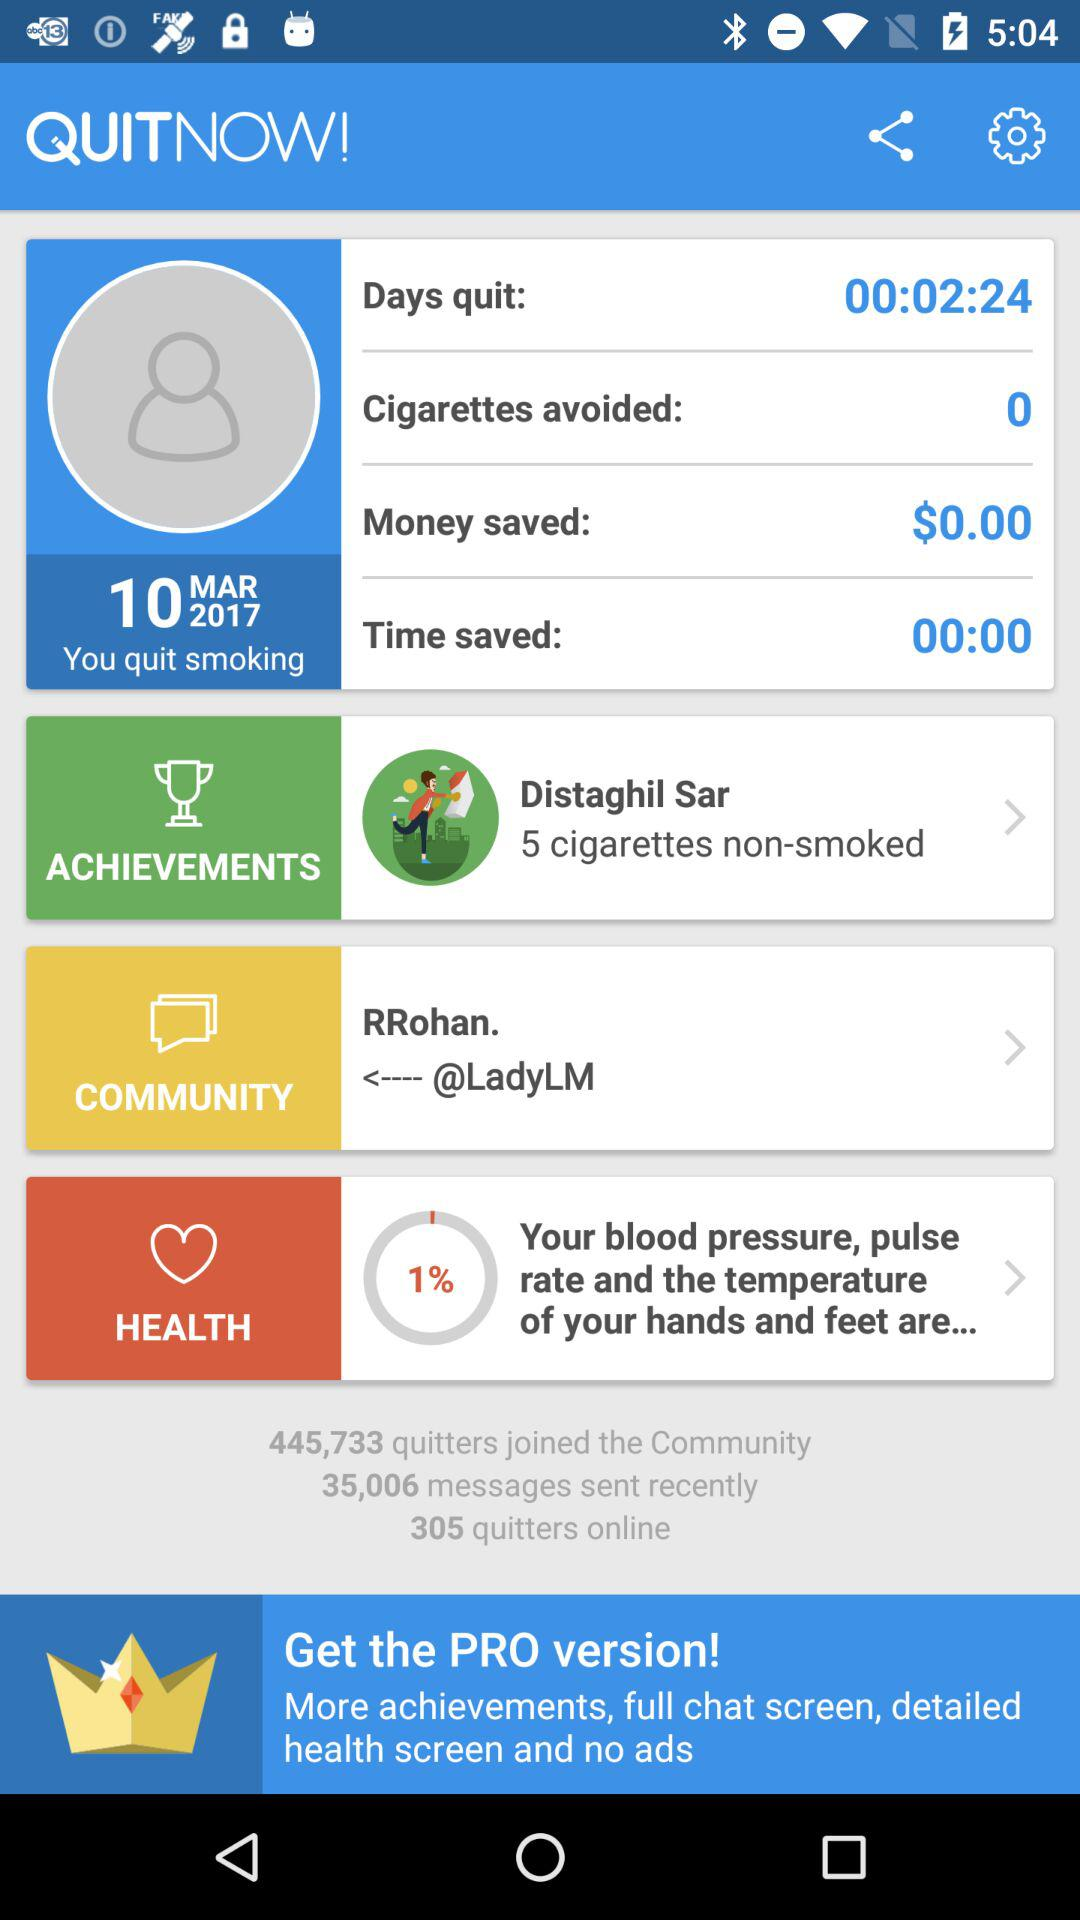What's the date the user quit smoking? The date is March 10, 2017. 